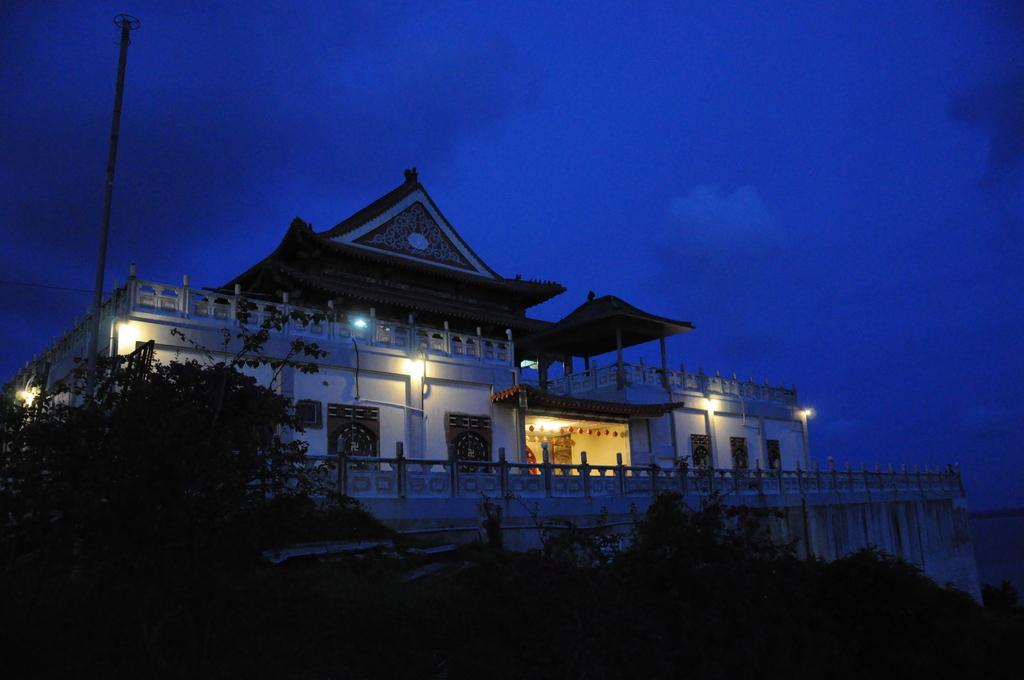Describe this image in one or two sentences. In this picture we can see the buildings. At the bottom we can see stars and trees. On the right side we can see fencing. At the top we can see sky and clouds. On the left there is a pole near to the wall. 